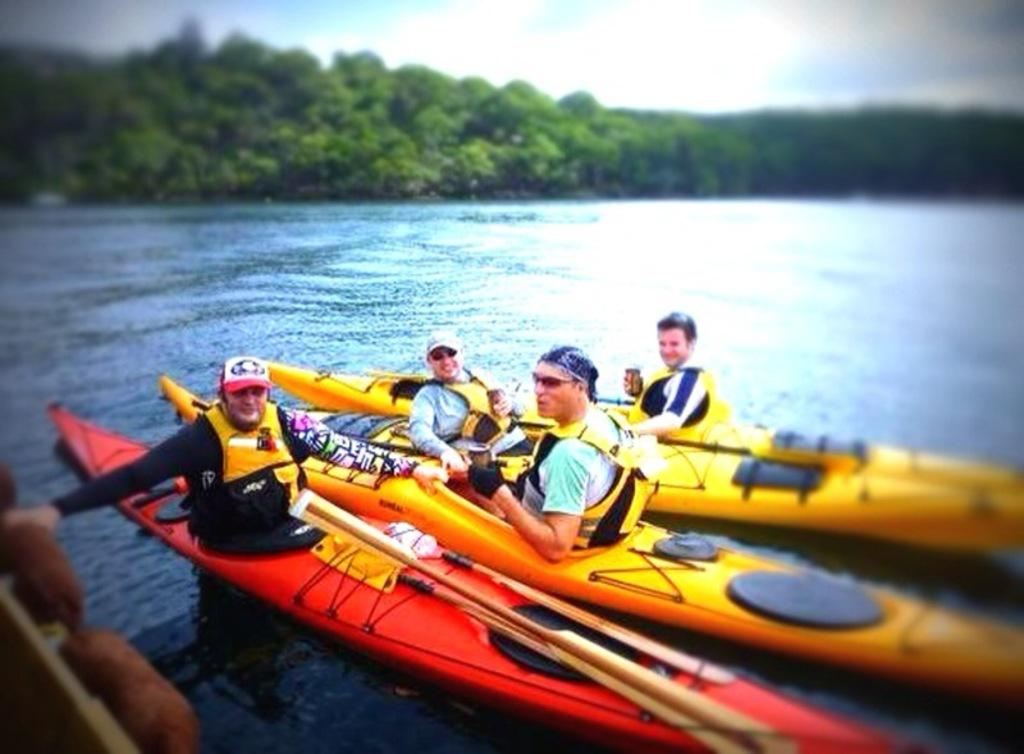How many people are in the image? There are four persons in the image. What are the persons doing in the image? The persons are sitting in kayaks. What are the kayaks equipped with? There are paddles in the image. Where are the kayaks located? The kayaks are on water. What can be seen in the background of the image? In the background, there is water, trees, and sky visible. What type of chalk is being used by the persons in the image? There is no chalk present in the image; the persons are sitting in kayaks on water. What religious ceremony is taking place in the image? There is no indication of a religious ceremony in the image; it features four persons in kayaks on water. 